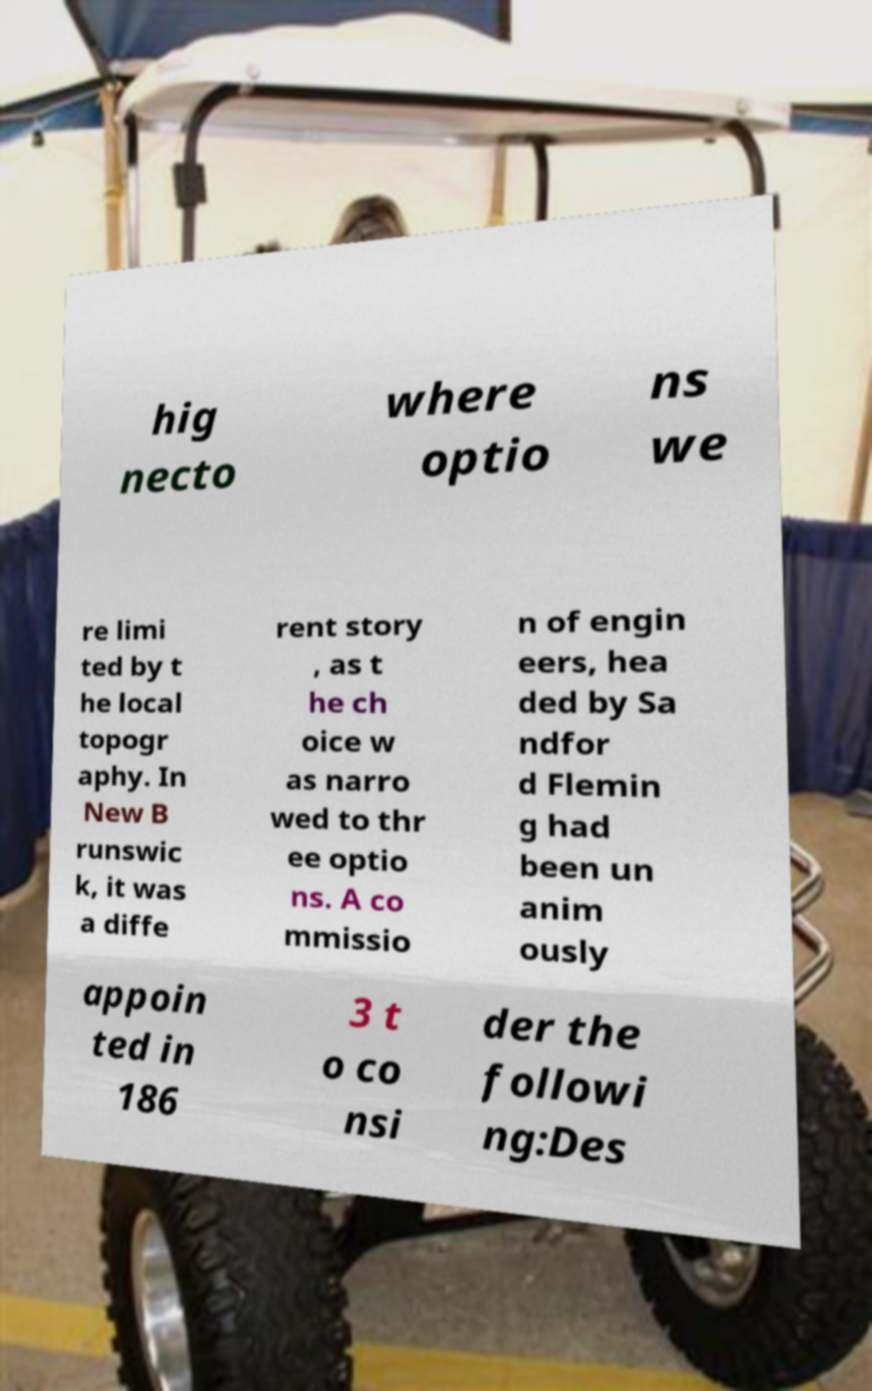Could you assist in decoding the text presented in this image and type it out clearly? hig necto where optio ns we re limi ted by t he local topogr aphy. In New B runswic k, it was a diffe rent story , as t he ch oice w as narro wed to thr ee optio ns. A co mmissio n of engin eers, hea ded by Sa ndfor d Flemin g had been un anim ously appoin ted in 186 3 t o co nsi der the followi ng:Des 